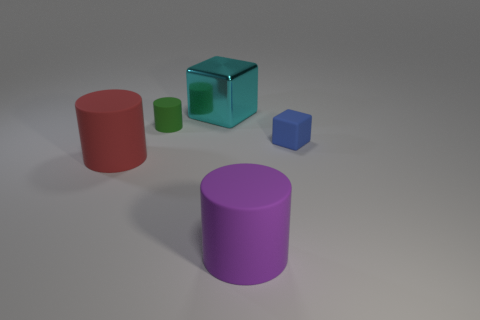Add 3 big green matte blocks. How many objects exist? 8 Subtract all cubes. How many objects are left? 3 Add 4 large cyan metal blocks. How many large cyan metal blocks exist? 5 Subtract 0 red cubes. How many objects are left? 5 Subtract all small red cylinders. Subtract all large purple objects. How many objects are left? 4 Add 2 matte things. How many matte things are left? 6 